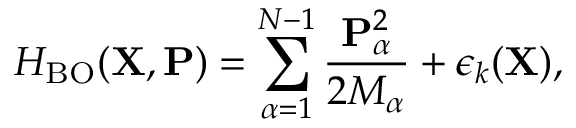Convert formula to latex. <formula><loc_0><loc_0><loc_500><loc_500>H _ { B O } ( { X } , { P } ) = \sum _ { \alpha = 1 } ^ { N - 1 } \frac { { P } _ { \alpha } ^ { 2 } } { 2 M _ { \alpha } } + \epsilon _ { k } ( { X } ) ,</formula> 